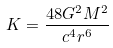<formula> <loc_0><loc_0><loc_500><loc_500>K = \frac { 4 8 G ^ { 2 } M ^ { 2 } } { c ^ { 4 } r ^ { 6 } }</formula> 